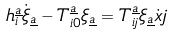<formula> <loc_0><loc_0><loc_500><loc_500>h _ { i } ^ { \underline { a } } \dot { \xi } _ { \underline { a } } - T _ { i 0 } ^ { \underline { a } } \xi _ { \underline { a } } = T _ { i j } ^ { \underline { a } } \xi _ { \underline { a } } \dot { x } j</formula> 